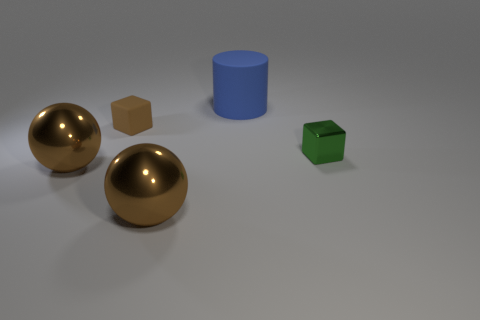There is a green object; is its shape the same as the big thing behind the tiny green metal object?
Provide a succinct answer. No. Are there any other things of the same color as the small metal object?
Offer a terse response. No. There is a block on the right side of the big blue object; is its color the same as the tiny object that is behind the small green metallic block?
Keep it short and to the point. No. Is there a large rubber thing?
Offer a terse response. Yes. Are there any large brown spheres that have the same material as the large blue cylinder?
Offer a terse response. No. Is there any other thing that has the same material as the green object?
Keep it short and to the point. Yes. What color is the matte cube?
Make the answer very short. Brown. What is the color of the thing that is the same size as the brown rubber cube?
Give a very brief answer. Green. What number of metallic things are blue cylinders or tiny cyan cylinders?
Give a very brief answer. 0. How many shiny objects are on the right side of the tiny brown matte object and left of the big blue thing?
Offer a terse response. 1. 